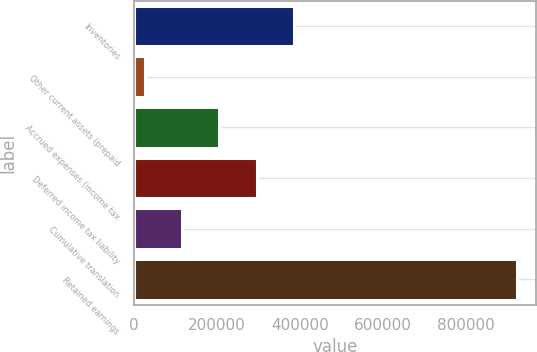Convert chart. <chart><loc_0><loc_0><loc_500><loc_500><bar_chart><fcel>Inventories<fcel>Other current assets (prepaid<fcel>Accrued expenses (income tax<fcel>Deferred income tax liability<fcel>Cumulative translation<fcel>Retained earnings<nl><fcel>384566<fcel>25876<fcel>205221<fcel>294893<fcel>115548<fcel>922600<nl></chart> 